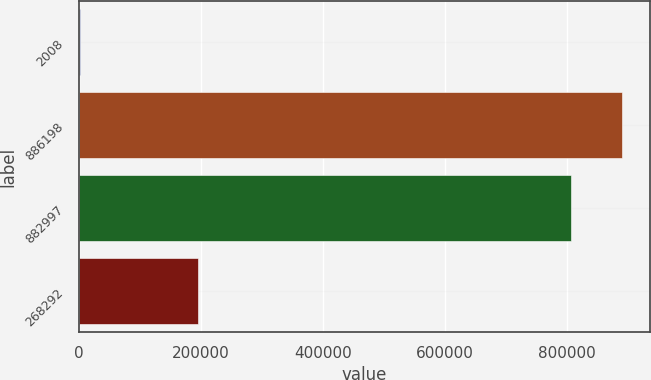<chart> <loc_0><loc_0><loc_500><loc_500><bar_chart><fcel>2008<fcel>886198<fcel>882997<fcel>268292<nl><fcel>2007<fcel>891051<fcel>806511<fcel>195835<nl></chart> 